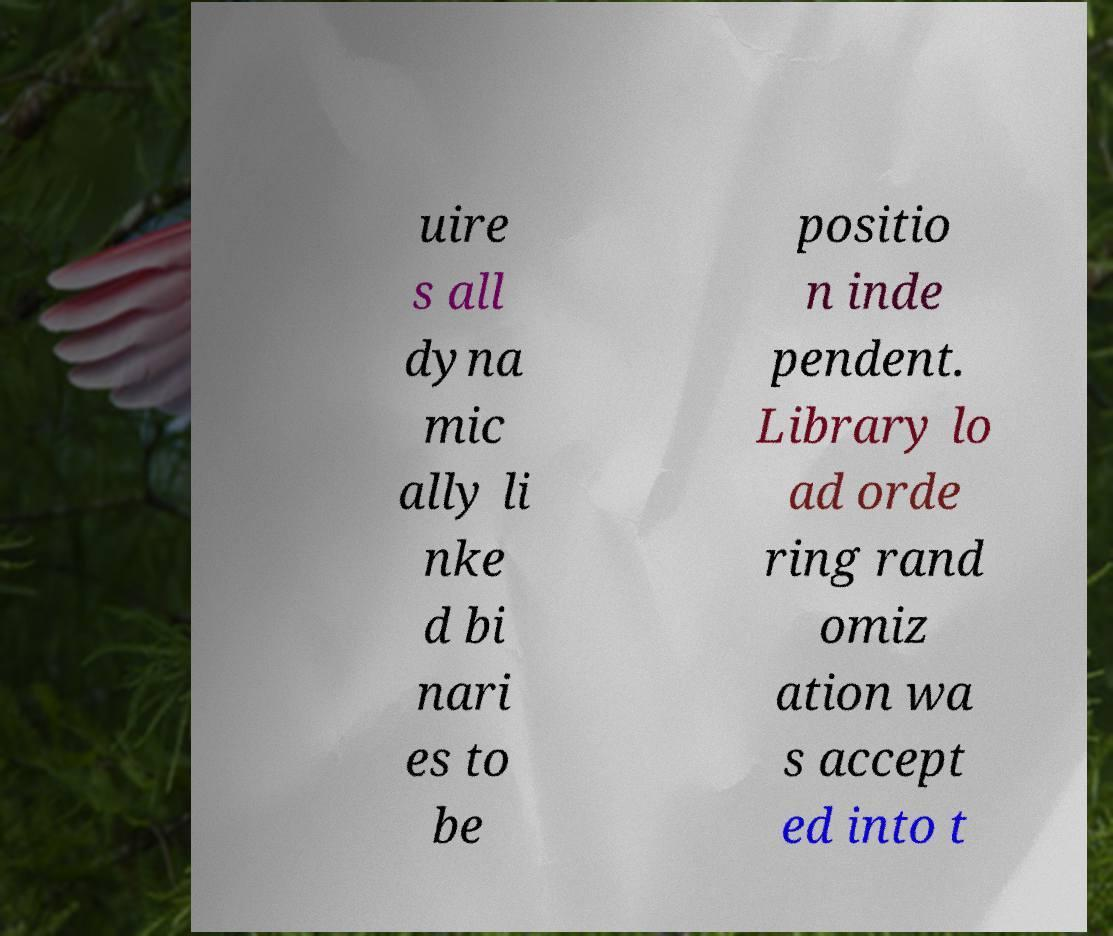Please read and relay the text visible in this image. What does it say? uire s all dyna mic ally li nke d bi nari es to be positio n inde pendent. Library lo ad orde ring rand omiz ation wa s accept ed into t 